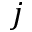Convert formula to latex. <formula><loc_0><loc_0><loc_500><loc_500>j</formula> 